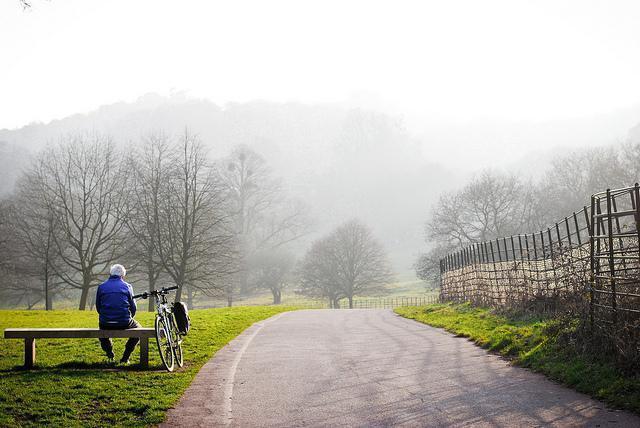Why is the sky so hazy?
Choose the right answer from the provided options to respond to the question.
Options: Fog, fire, magic trick, factory smoke. Fog. 